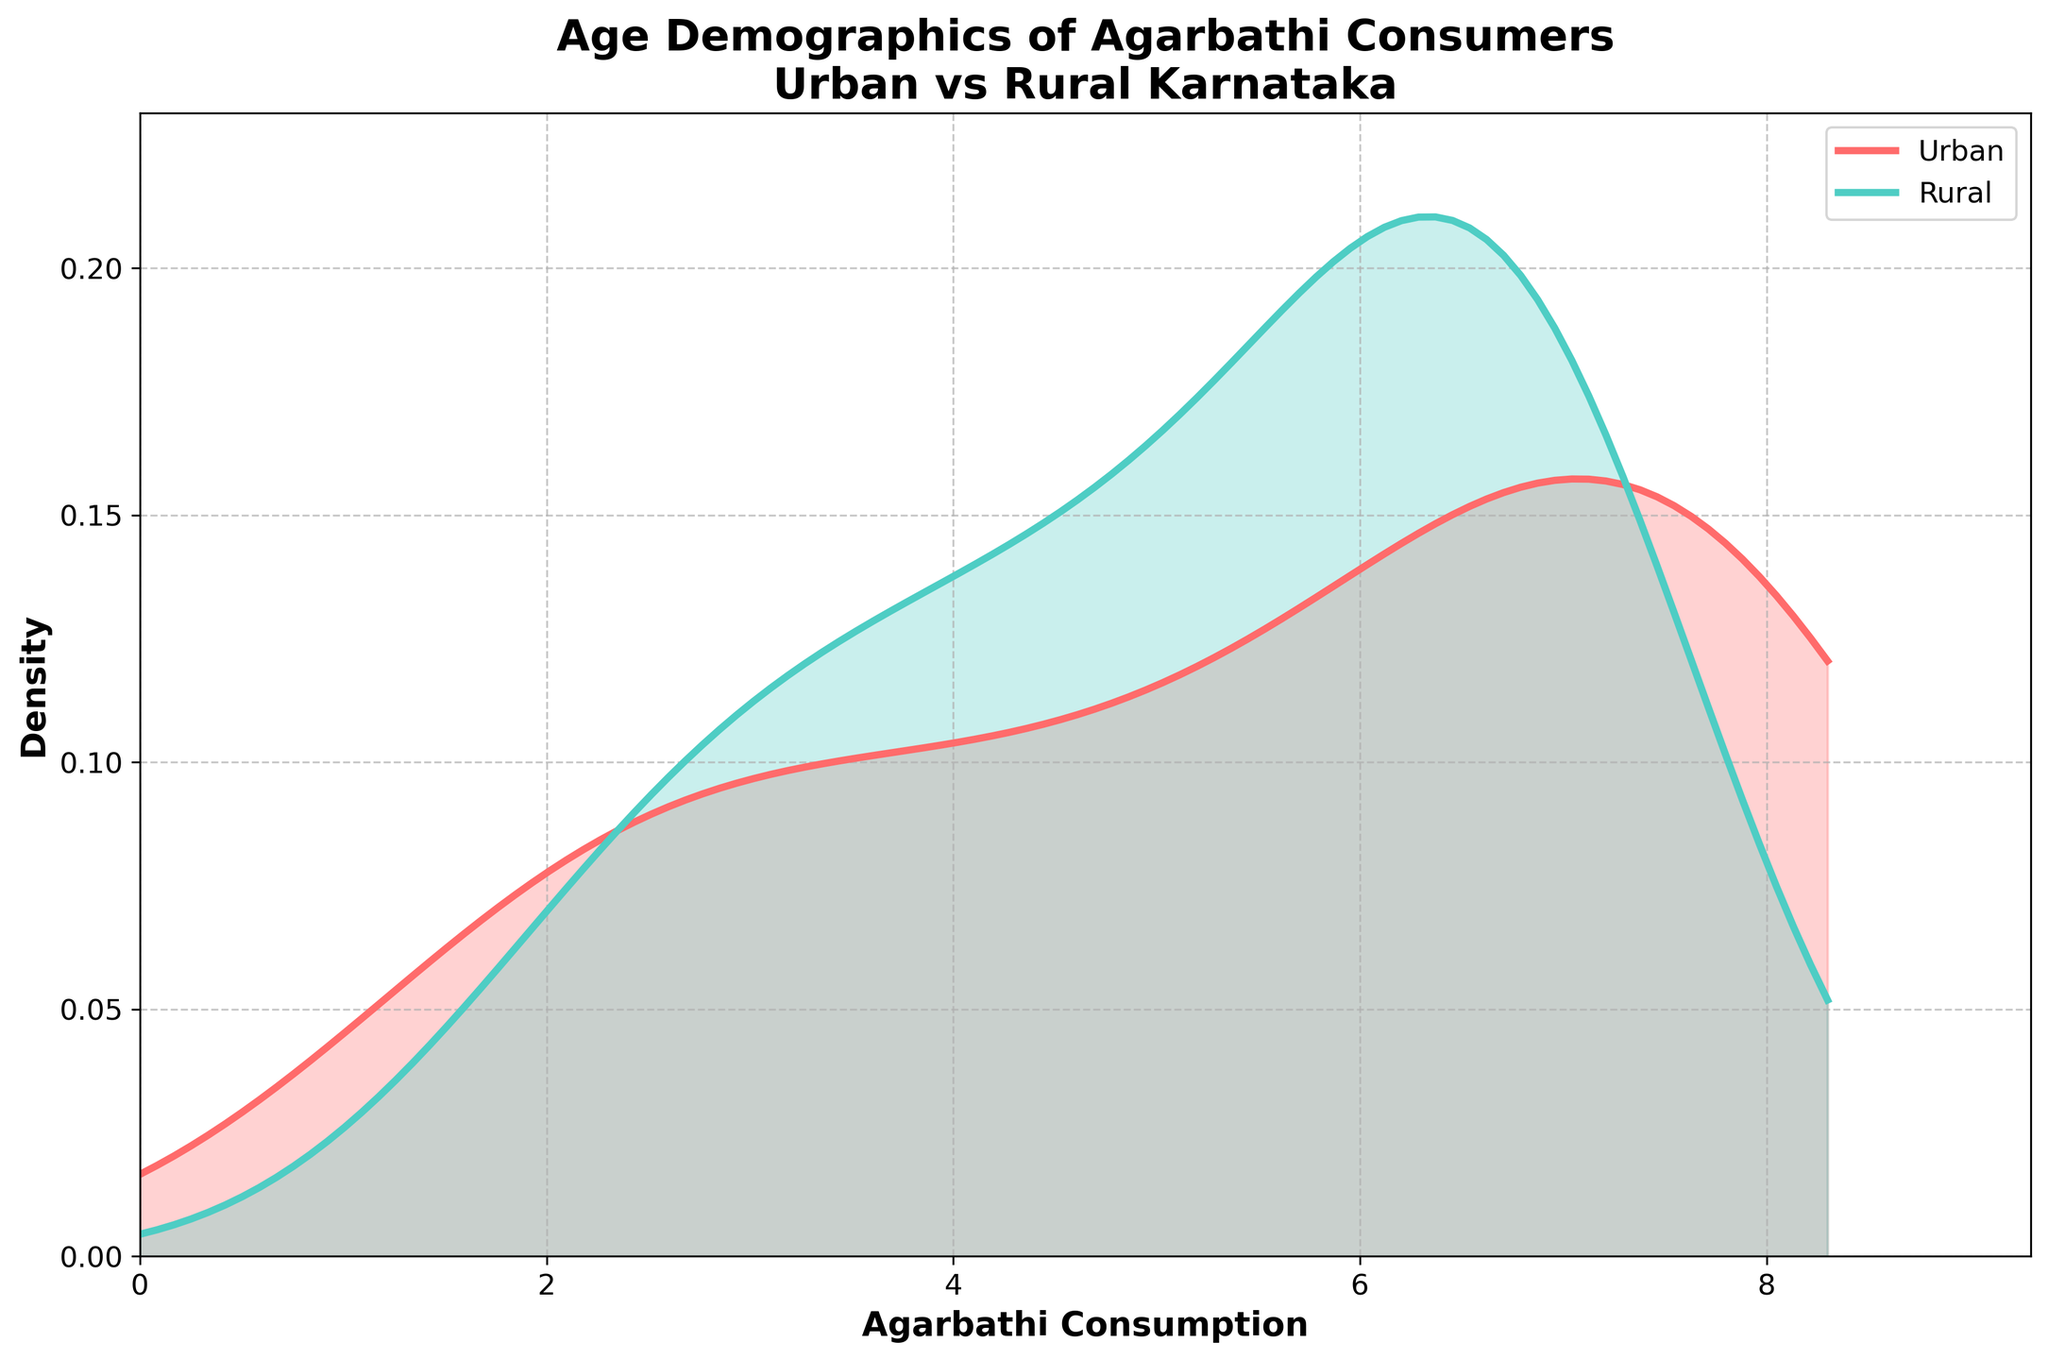What is the title of the plot? The title of the plot is displayed at the top of the figure. It gives an overview of what the plot represents.
Answer: Age Demographics of Agarbathi Consumers Urban vs Rural Karnataka What colors are used to represent Urban and Rural areas in the plot? Urban areas are represented by one color and Rural areas by another, making it easy to differentiate between the two groups on the density plot.
Answer: Urban is red and Rural is teal Which axis represents Agarbathi Consumption? The labels on the axes mention what each axis represents. By looking at the label, we can determine which axis corresponds to Agarbathi Consumption.
Answer: The x-axis What is the peak density value for Urban consumers? By checking the highest point of the density curve for Urban areas, we can find the peak density value.
Answer: Approximately 8.3 Between which age ranges do Urban consumers show the highest density of agarbathi consumption? By examining the highest peaks and the x-values corresponding to these peaks on the Urban density plot, we can determine the age range.
Answer: Between ages 46 and 54 How does the density of agarbathi consumption in Rural areas compare to Urban areas at age 62? Compare the values at age 62 for both Urban and Rural areas on the density plot to determine which is higher.
Answer: Rural density is higher than Urban density Which age group shows a decreasing trend in agarbathi consumption for Urban consumers after its peak? Identify the peak of the Urban density curve and observe how the values change after this point to find the age group showing a decreasing trend.
Answer: Ages above 54 Is there an age group where Rural consumers' density surpasses Urban consumers? Compare both density curves across different age groups to find any intersection points where Rural density is higher than Urban density.
Answer: Yes, around ages 62 and onward What is common between the trends of agarbathi consumption in Urban and Rural areas based on the density plot? Observe both curves for any similar trends or patterns in the age demographics of agarbathi consumption.
Answer: Both have peaks in middle-aged groups and decline in older ages What can you infer about agarbathi consumption patterns in Urban vs. Rural areas from this plot? Analyzing both curves together, noticing peaks, valleys, and trends can lead to insights about consumption patterns across different demographics.
Answer: Urban areas have higher consumption among middle-aged individuals, while Rural areas have a more consistent spread with a peak in older age 